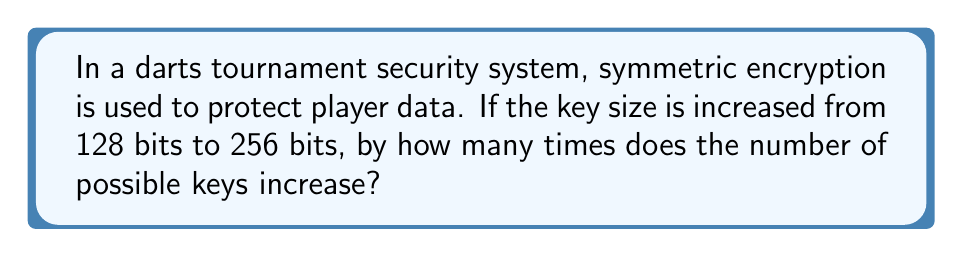Show me your answer to this math problem. Let's approach this step-by-step:

1) In symmetric encryption, the number of possible keys is determined by 2 raised to the power of the key size in bits.

2) For a 128-bit key:
   Number of possible keys = $2^{128}$

3) For a 256-bit key:
   Number of possible keys = $2^{256}$

4) To find how many times the number of keys increases, we divide the number of keys for 256-bit by the number of keys for 128-bit:

   $$\frac{2^{256}}{2^{128}}$$

5) Using the laws of exponents, when dividing powers with the same base, we subtract the exponents:

   $$2^{256-128} = 2^{128}$$

6) Therefore, the number of possible keys increases by a factor of $2^{128}$.

This immense increase in the number of possible keys significantly enhances the security of the encryption, making it much more resistant to brute-force attacks.
Answer: $2^{128}$ times 